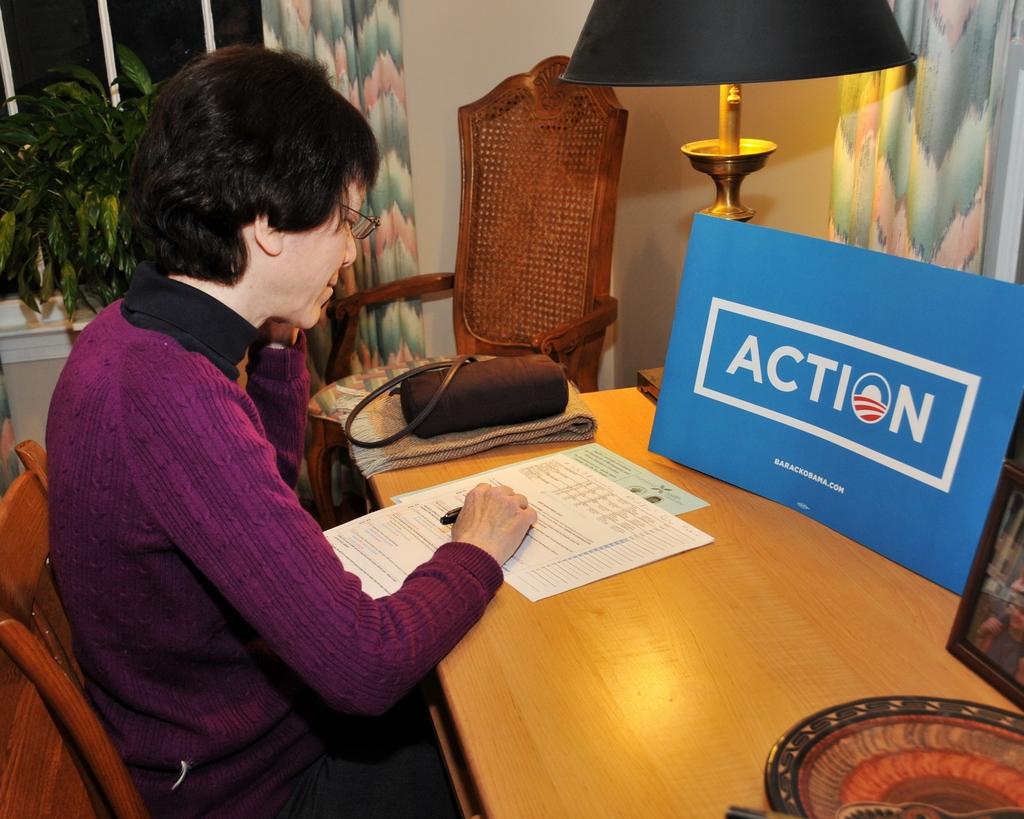What is the name on the blue board?
Your answer should be very brief. Action. 